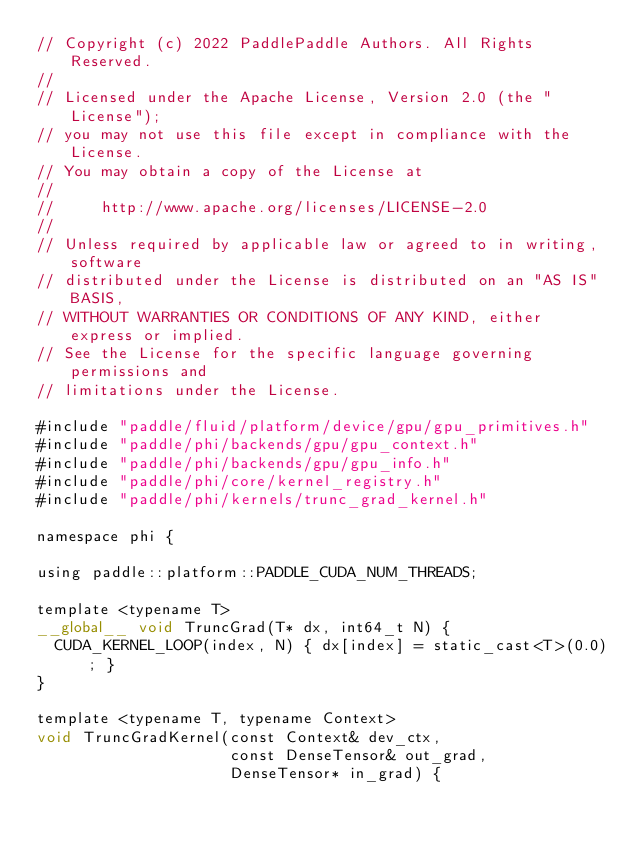<code> <loc_0><loc_0><loc_500><loc_500><_Cuda_>// Copyright (c) 2022 PaddlePaddle Authors. All Rights Reserved.
//
// Licensed under the Apache License, Version 2.0 (the "License");
// you may not use this file except in compliance with the License.
// You may obtain a copy of the License at
//
//     http://www.apache.org/licenses/LICENSE-2.0
//
// Unless required by applicable law or agreed to in writing, software
// distributed under the License is distributed on an "AS IS" BASIS,
// WITHOUT WARRANTIES OR CONDITIONS OF ANY KIND, either express or implied.
// See the License for the specific language governing permissions and
// limitations under the License.

#include "paddle/fluid/platform/device/gpu/gpu_primitives.h"
#include "paddle/phi/backends/gpu/gpu_context.h"
#include "paddle/phi/backends/gpu/gpu_info.h"
#include "paddle/phi/core/kernel_registry.h"
#include "paddle/phi/kernels/trunc_grad_kernel.h"

namespace phi {

using paddle::platform::PADDLE_CUDA_NUM_THREADS;

template <typename T>
__global__ void TruncGrad(T* dx, int64_t N) {
  CUDA_KERNEL_LOOP(index, N) { dx[index] = static_cast<T>(0.0); }
}

template <typename T, typename Context>
void TruncGradKernel(const Context& dev_ctx,
                     const DenseTensor& out_grad,
                     DenseTensor* in_grad) {</code> 